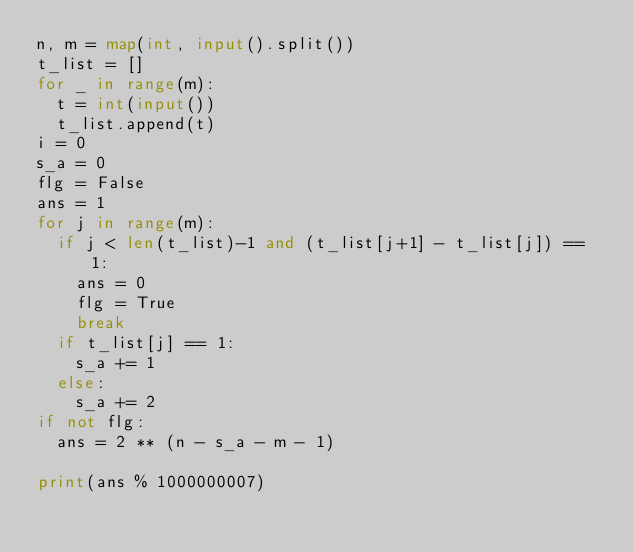Convert code to text. <code><loc_0><loc_0><loc_500><loc_500><_Python_>n, m = map(int, input().split())
t_list = []
for _ in range(m):
  t = int(input())
  t_list.append(t)
i = 0
s_a = 0
flg = False
ans = 1
for j in range(m):
  if j < len(t_list)-1 and (t_list[j+1] - t_list[j]) == 1:
    ans = 0
    flg = True
    break
  if t_list[j] == 1:
    s_a += 1
  else:
    s_a += 2
if not flg:
  ans = 2 ** (n - s_a - m - 1)
    
print(ans % 1000000007)</code> 